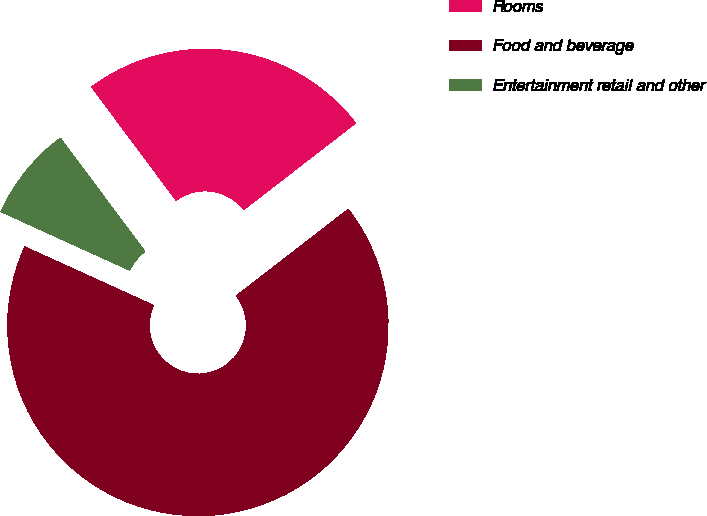<chart> <loc_0><loc_0><loc_500><loc_500><pie_chart><fcel>Rooms<fcel>Food and beverage<fcel>Entertainment retail and other<nl><fcel>24.72%<fcel>67.27%<fcel>8.01%<nl></chart> 